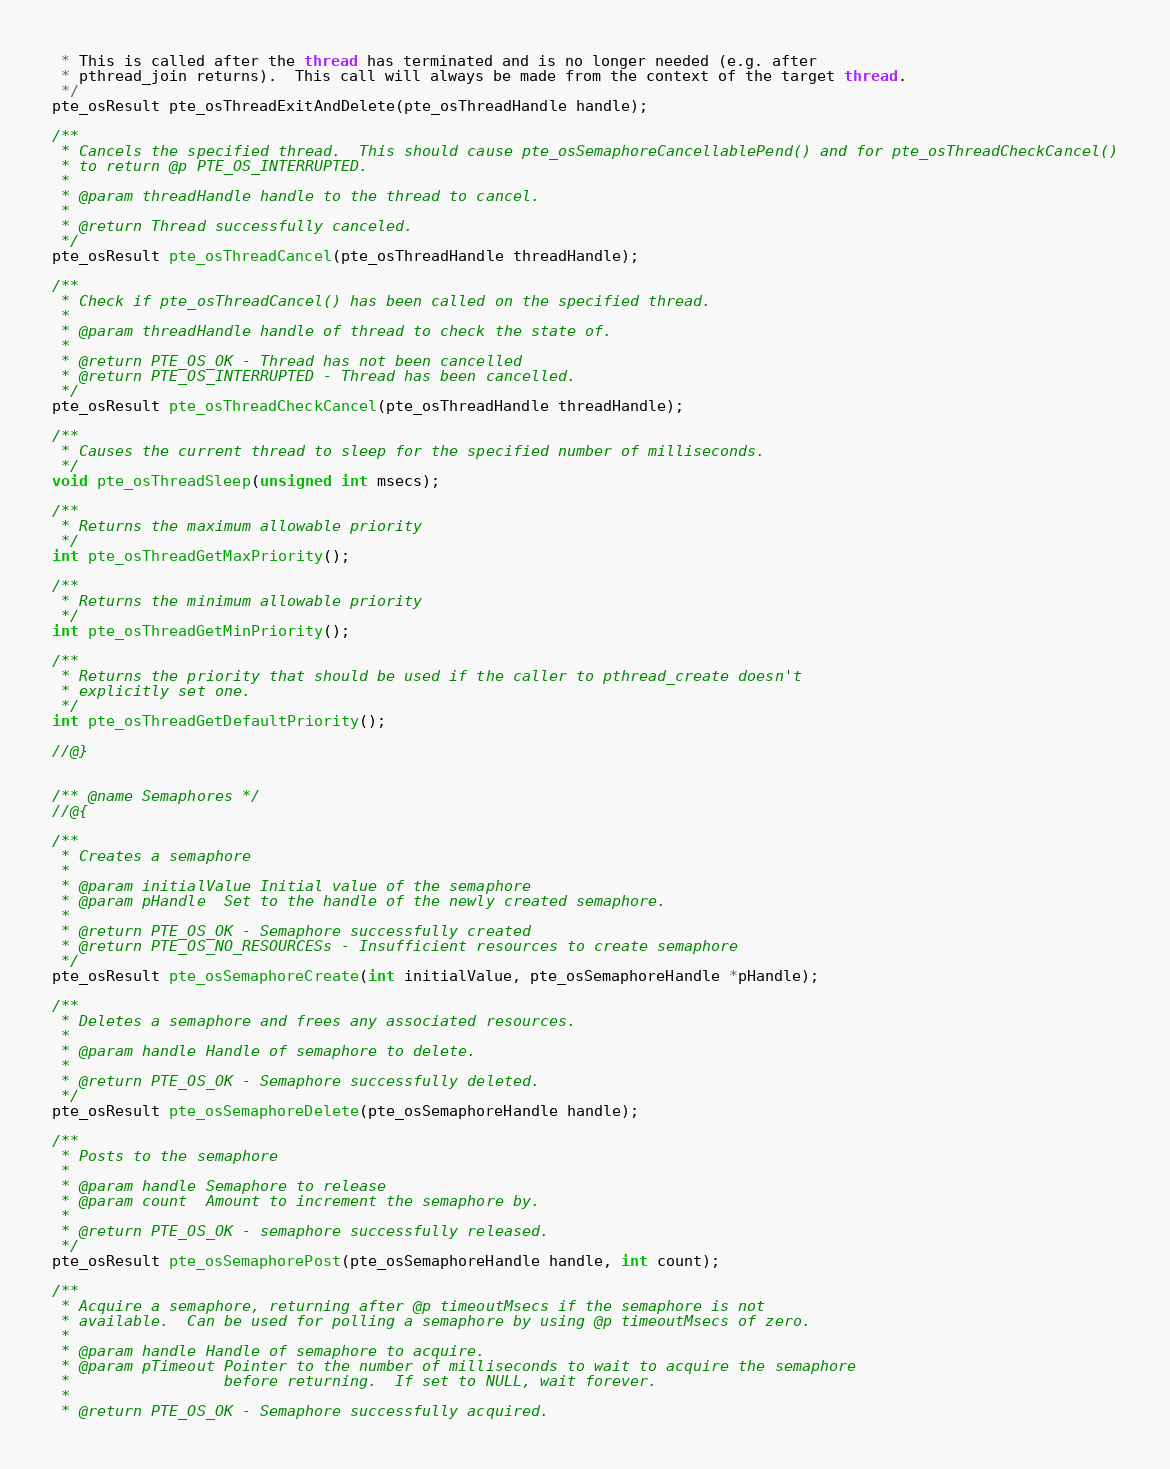<code> <loc_0><loc_0><loc_500><loc_500><_C_> * This is called after the thread has terminated and is no longer needed (e.g. after
 * pthread_join returns).  This call will always be made from the context of the target thread.
 */
pte_osResult pte_osThreadExitAndDelete(pte_osThreadHandle handle);

/**
 * Cancels the specified thread.  This should cause pte_osSemaphoreCancellablePend() and for pte_osThreadCheckCancel()
 * to return @p PTE_OS_INTERRUPTED.
 *
 * @param threadHandle handle to the thread to cancel.
 *
 * @return Thread successfully canceled.
 */
pte_osResult pte_osThreadCancel(pte_osThreadHandle threadHandle);

/**
 * Check if pte_osThreadCancel() has been called on the specified thread.
 *
 * @param threadHandle handle of thread to check the state of.
 *
 * @return PTE_OS_OK - Thread has not been cancelled
 * @return PTE_OS_INTERRUPTED - Thread has been cancelled.
 */
pte_osResult pte_osThreadCheckCancel(pte_osThreadHandle threadHandle);

/**
 * Causes the current thread to sleep for the specified number of milliseconds.
 */
void pte_osThreadSleep(unsigned int msecs);

/**
 * Returns the maximum allowable priority
 */
int pte_osThreadGetMaxPriority();

/**
 * Returns the minimum allowable priority
 */
int pte_osThreadGetMinPriority();

/**
 * Returns the priority that should be used if the caller to pthread_create doesn't
 * explicitly set one.
 */
int pte_osThreadGetDefaultPriority();

//@}


/** @name Semaphores */
//@{

/**
 * Creates a semaphore
 *
 * @param initialValue Initial value of the semaphore
 * @param pHandle  Set to the handle of the newly created semaphore.
 *
 * @return PTE_OS_OK - Semaphore successfully created
 * @return PTE_OS_NO_RESOURCESs - Insufficient resources to create semaphore
 */
pte_osResult pte_osSemaphoreCreate(int initialValue, pte_osSemaphoreHandle *pHandle);

/**
 * Deletes a semaphore and frees any associated resources.
 *
 * @param handle Handle of semaphore to delete.
 *
 * @return PTE_OS_OK - Semaphore successfully deleted.
 */
pte_osResult pte_osSemaphoreDelete(pte_osSemaphoreHandle handle);

/**
 * Posts to the semaphore
 *
 * @param handle Semaphore to release
 * @param count  Amount to increment the semaphore by.
 *
 * @return PTE_OS_OK - semaphore successfully released.
 */
pte_osResult pte_osSemaphorePost(pte_osSemaphoreHandle handle, int count);

/**
 * Acquire a semaphore, returning after @p timeoutMsecs if the semaphore is not
 * available.  Can be used for polling a semaphore by using @p timeoutMsecs of zero.
 *
 * @param handle Handle of semaphore to acquire.
 * @param pTimeout Pointer to the number of milliseconds to wait to acquire the semaphore
 *                 before returning.  If set to NULL, wait forever.
 *
 * @return PTE_OS_OK - Semaphore successfully acquired.</code> 